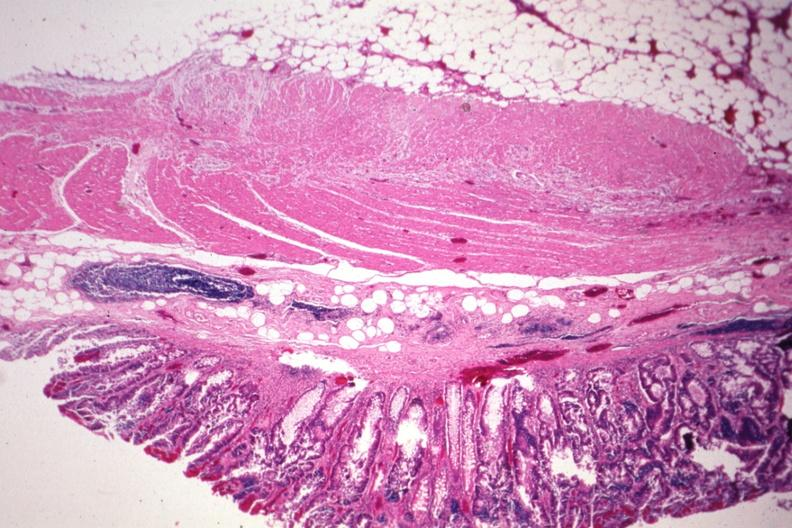what is present?
Answer the question using a single word or phrase. Gastrointestinal 